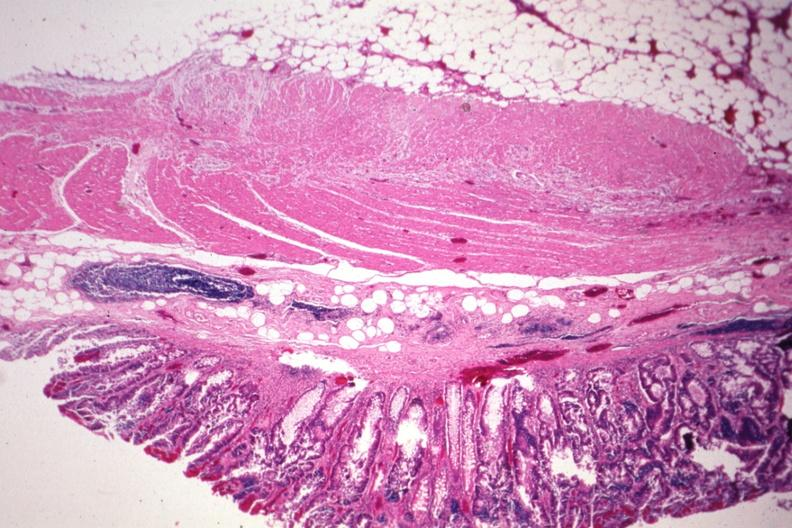what is present?
Answer the question using a single word or phrase. Gastrointestinal 